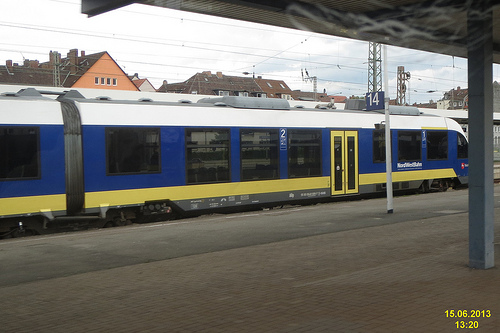Is there any train to the right of the tower made of metal? No, there is no train to the right of the metal tower in this image, only the platform is visible. 